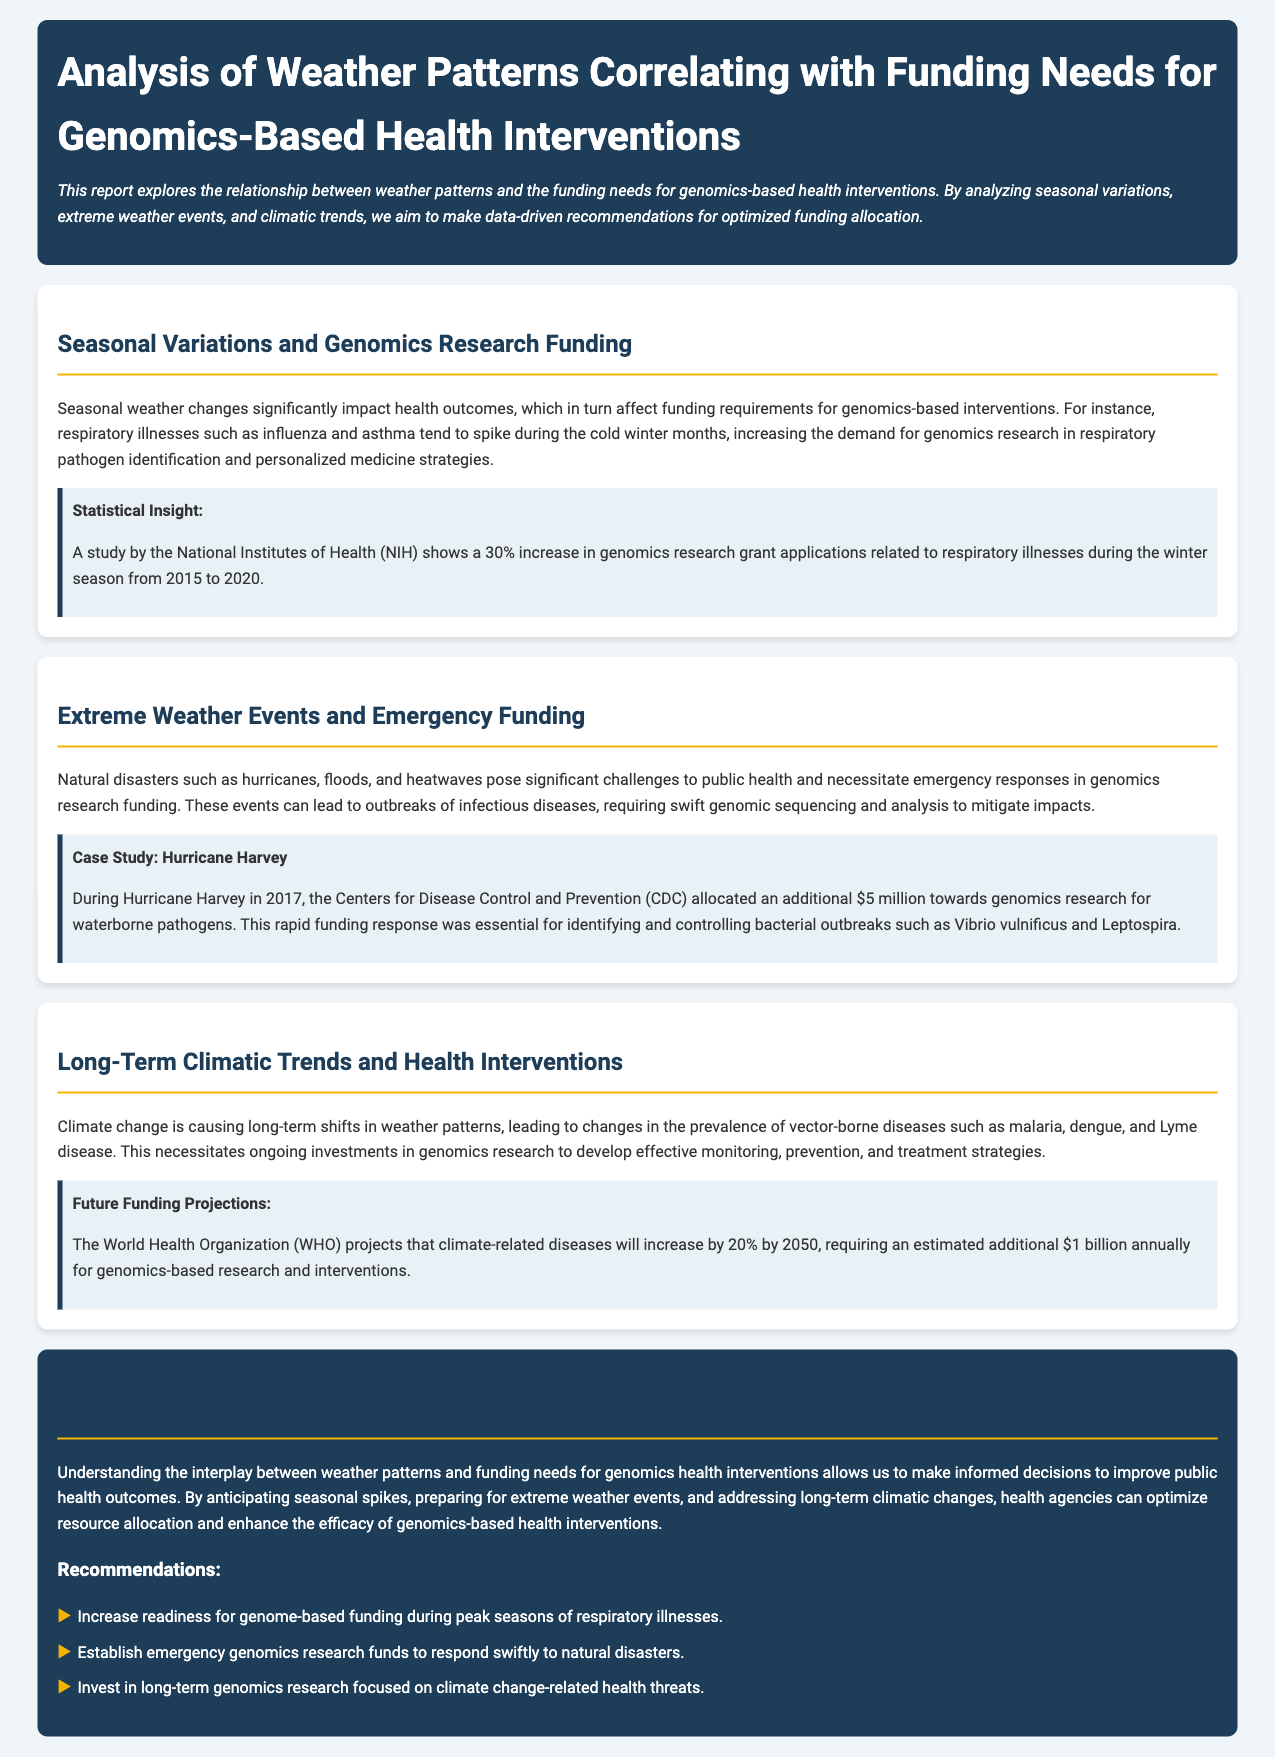What is the main focus of the report? The report explores the relationship between weather patterns and funding needs for genomics-based health interventions.
Answer: Weather patterns and funding needs What was the percentage increase in genomics research grant applications during winter? The report specifies that there was a 30% increase in genomics research grant applications related to respiratory illnesses during the winter season from 2015 to 2020.
Answer: 30% What significant case study is mentioned in the document? The case study highlighted in the report is about Hurricane Harvey in 2017, which led to additional funding for genomics research.
Answer: Hurricane Harvey What additional funding amount was allocated by the CDC during Hurricane Harvey? The document states that the CDC allocated an additional $5 million towards genomics research for waterborne pathogens during Hurricane Harvey.
Answer: $5 million By what percentage does the WHO project climate-related diseases will increase by 2050? The World Health Organization projects that climate-related diseases will increase by 20% by 2050.
Answer: 20% What type of emergencies does the report suggest funding should be prepared for? The report mentions the need for establishing emergency genomics research funds to respond to natural disasters.
Answer: Natural disasters What is one of the recommendations provided in the conclusion? The recommendations include increasing readiness for genome-based funding during peak seasons of respiratory illnesses.
Answer: Increase readiness for genome-based funding What does the report indicate about the expected investment for genomics research by 2050? It mentions that an estimated additional $1 billion annually will be required for genomics-based research and interventions due to climate change-related diseases.
Answer: $1 billion 